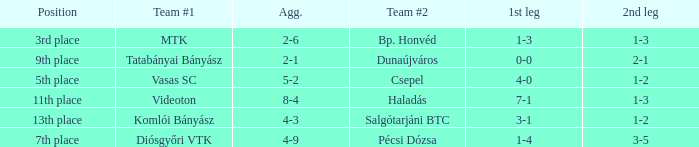How many positions correspond to a 1-3 1st leg? 1.0. 